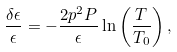<formula> <loc_0><loc_0><loc_500><loc_500>\frac { \delta \epsilon } { \epsilon } = - \frac { 2 p ^ { 2 } P } { \epsilon } \ln \left ( \frac { T } { T _ { 0 } } \right ) ,</formula> 